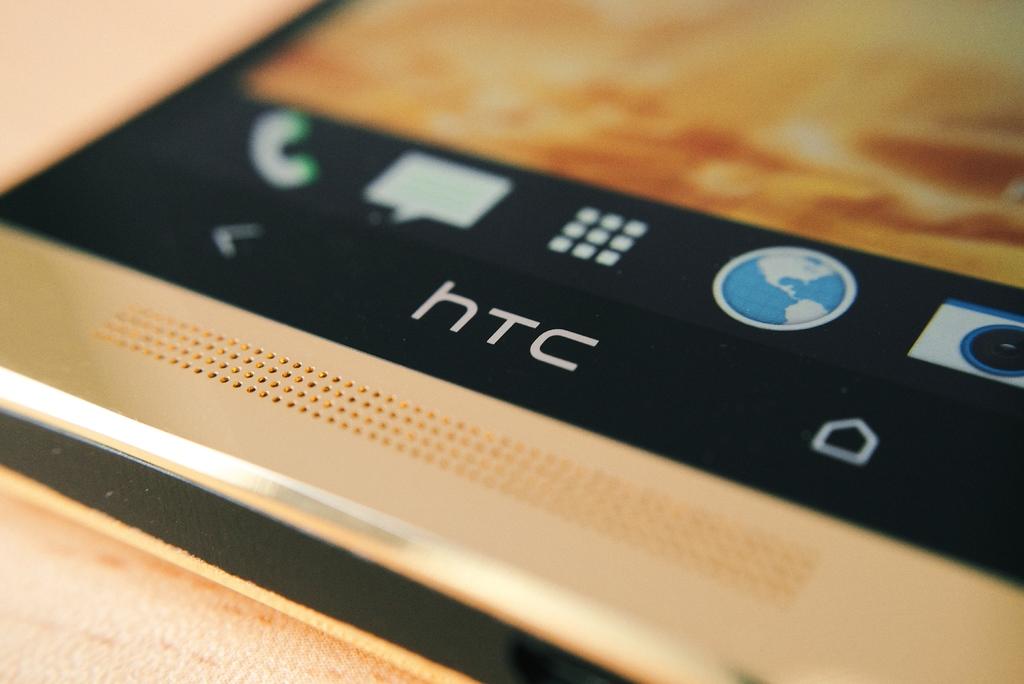What brand phone is this?
Your answer should be compact. Htc. 